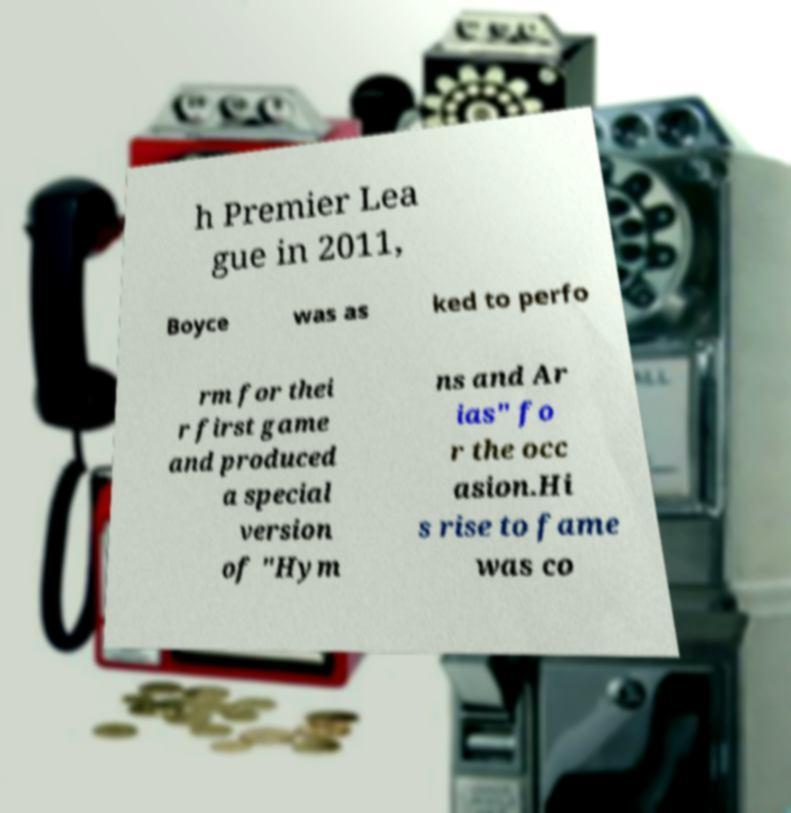I need the written content from this picture converted into text. Can you do that? h Premier Lea gue in 2011, Boyce was as ked to perfo rm for thei r first game and produced a special version of "Hym ns and Ar ias" fo r the occ asion.Hi s rise to fame was co 